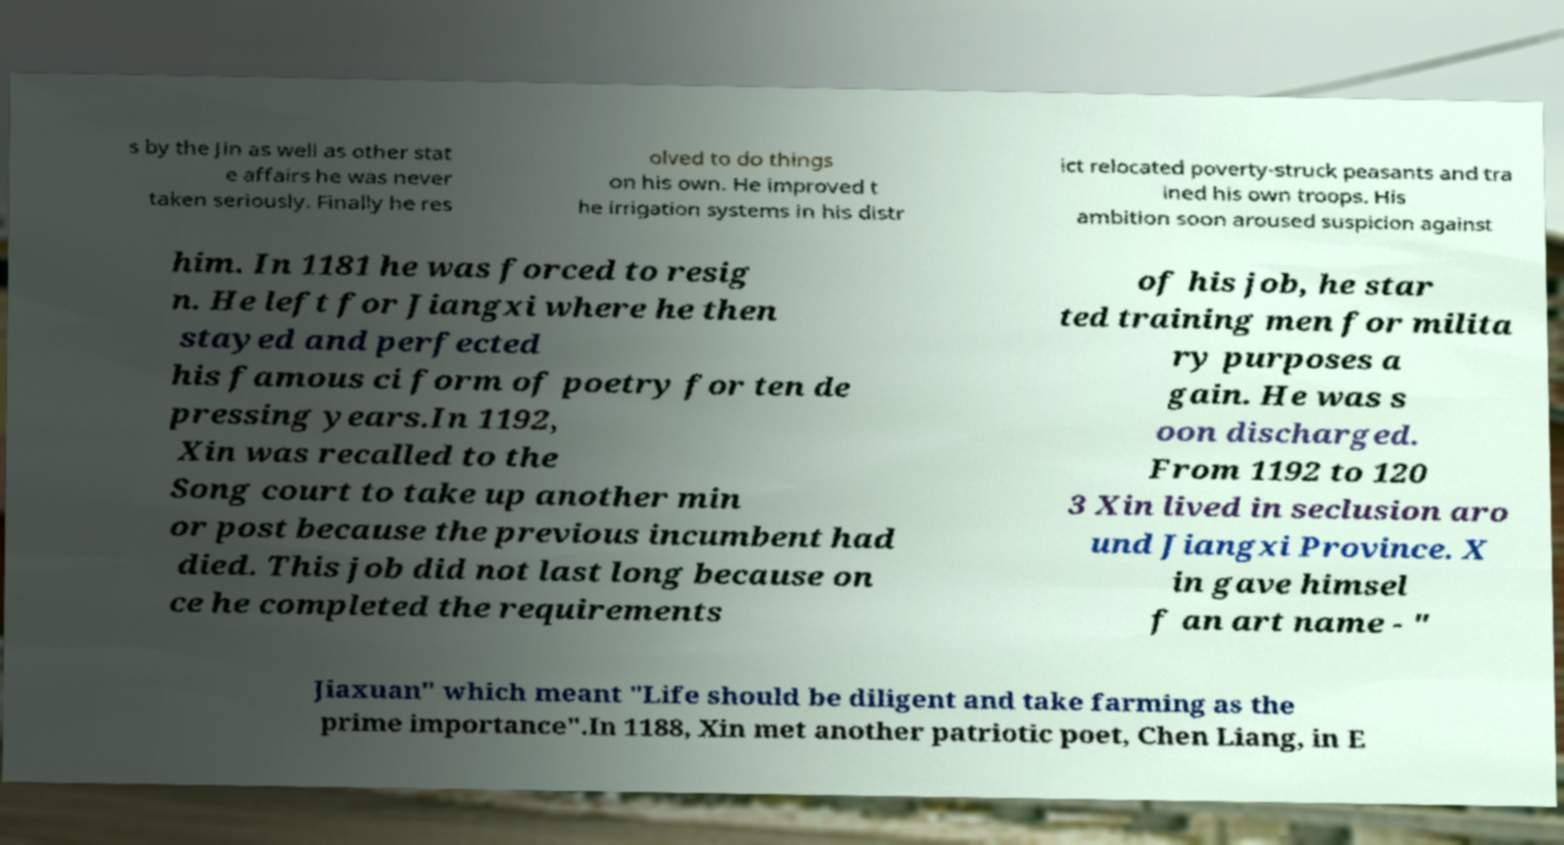For documentation purposes, I need the text within this image transcribed. Could you provide that? s by the Jin as well as other stat e affairs he was never taken seriously. Finally he res olved to do things on his own. He improved t he irrigation systems in his distr ict relocated poverty-struck peasants and tra ined his own troops. His ambition soon aroused suspicion against him. In 1181 he was forced to resig n. He left for Jiangxi where he then stayed and perfected his famous ci form of poetry for ten de pressing years.In 1192, Xin was recalled to the Song court to take up another min or post because the previous incumbent had died. This job did not last long because on ce he completed the requirements of his job, he star ted training men for milita ry purposes a gain. He was s oon discharged. From 1192 to 120 3 Xin lived in seclusion aro und Jiangxi Province. X in gave himsel f an art name - " Jiaxuan" which meant "Life should be diligent and take farming as the prime importance".In 1188, Xin met another patriotic poet, Chen Liang, in E 